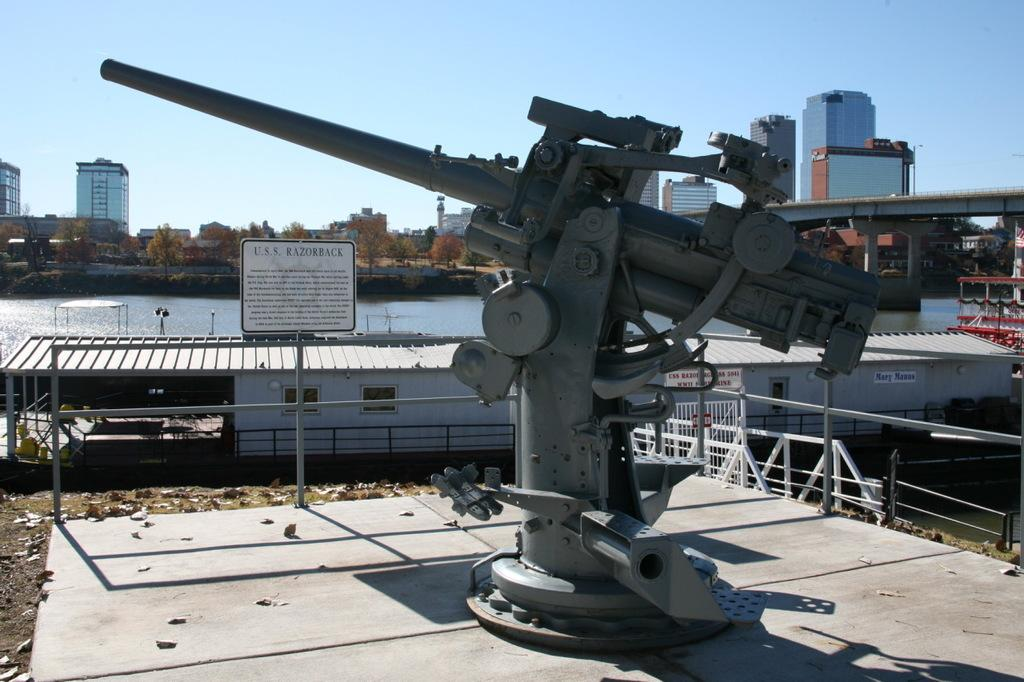What is the main object on the surface in the image? There is a naval gun on the surface in the image. What other objects can be seen on the surface? There are rods, railings, boards, and poles visible in the image. What type of structure is present in the image? There is a shed in the image. What can be seen in the background of the image? There is water, a bridge, buildings, trees, and the sky visible in the background of the image. How many ducks are sitting on the sidewalk in the image? There are no ducks or sidewalks present in the image. What is the color of the elbow on the naval gun in the image? There is no elbow on the naval gun in the image, as it is a mechanical object and not a human body part. 